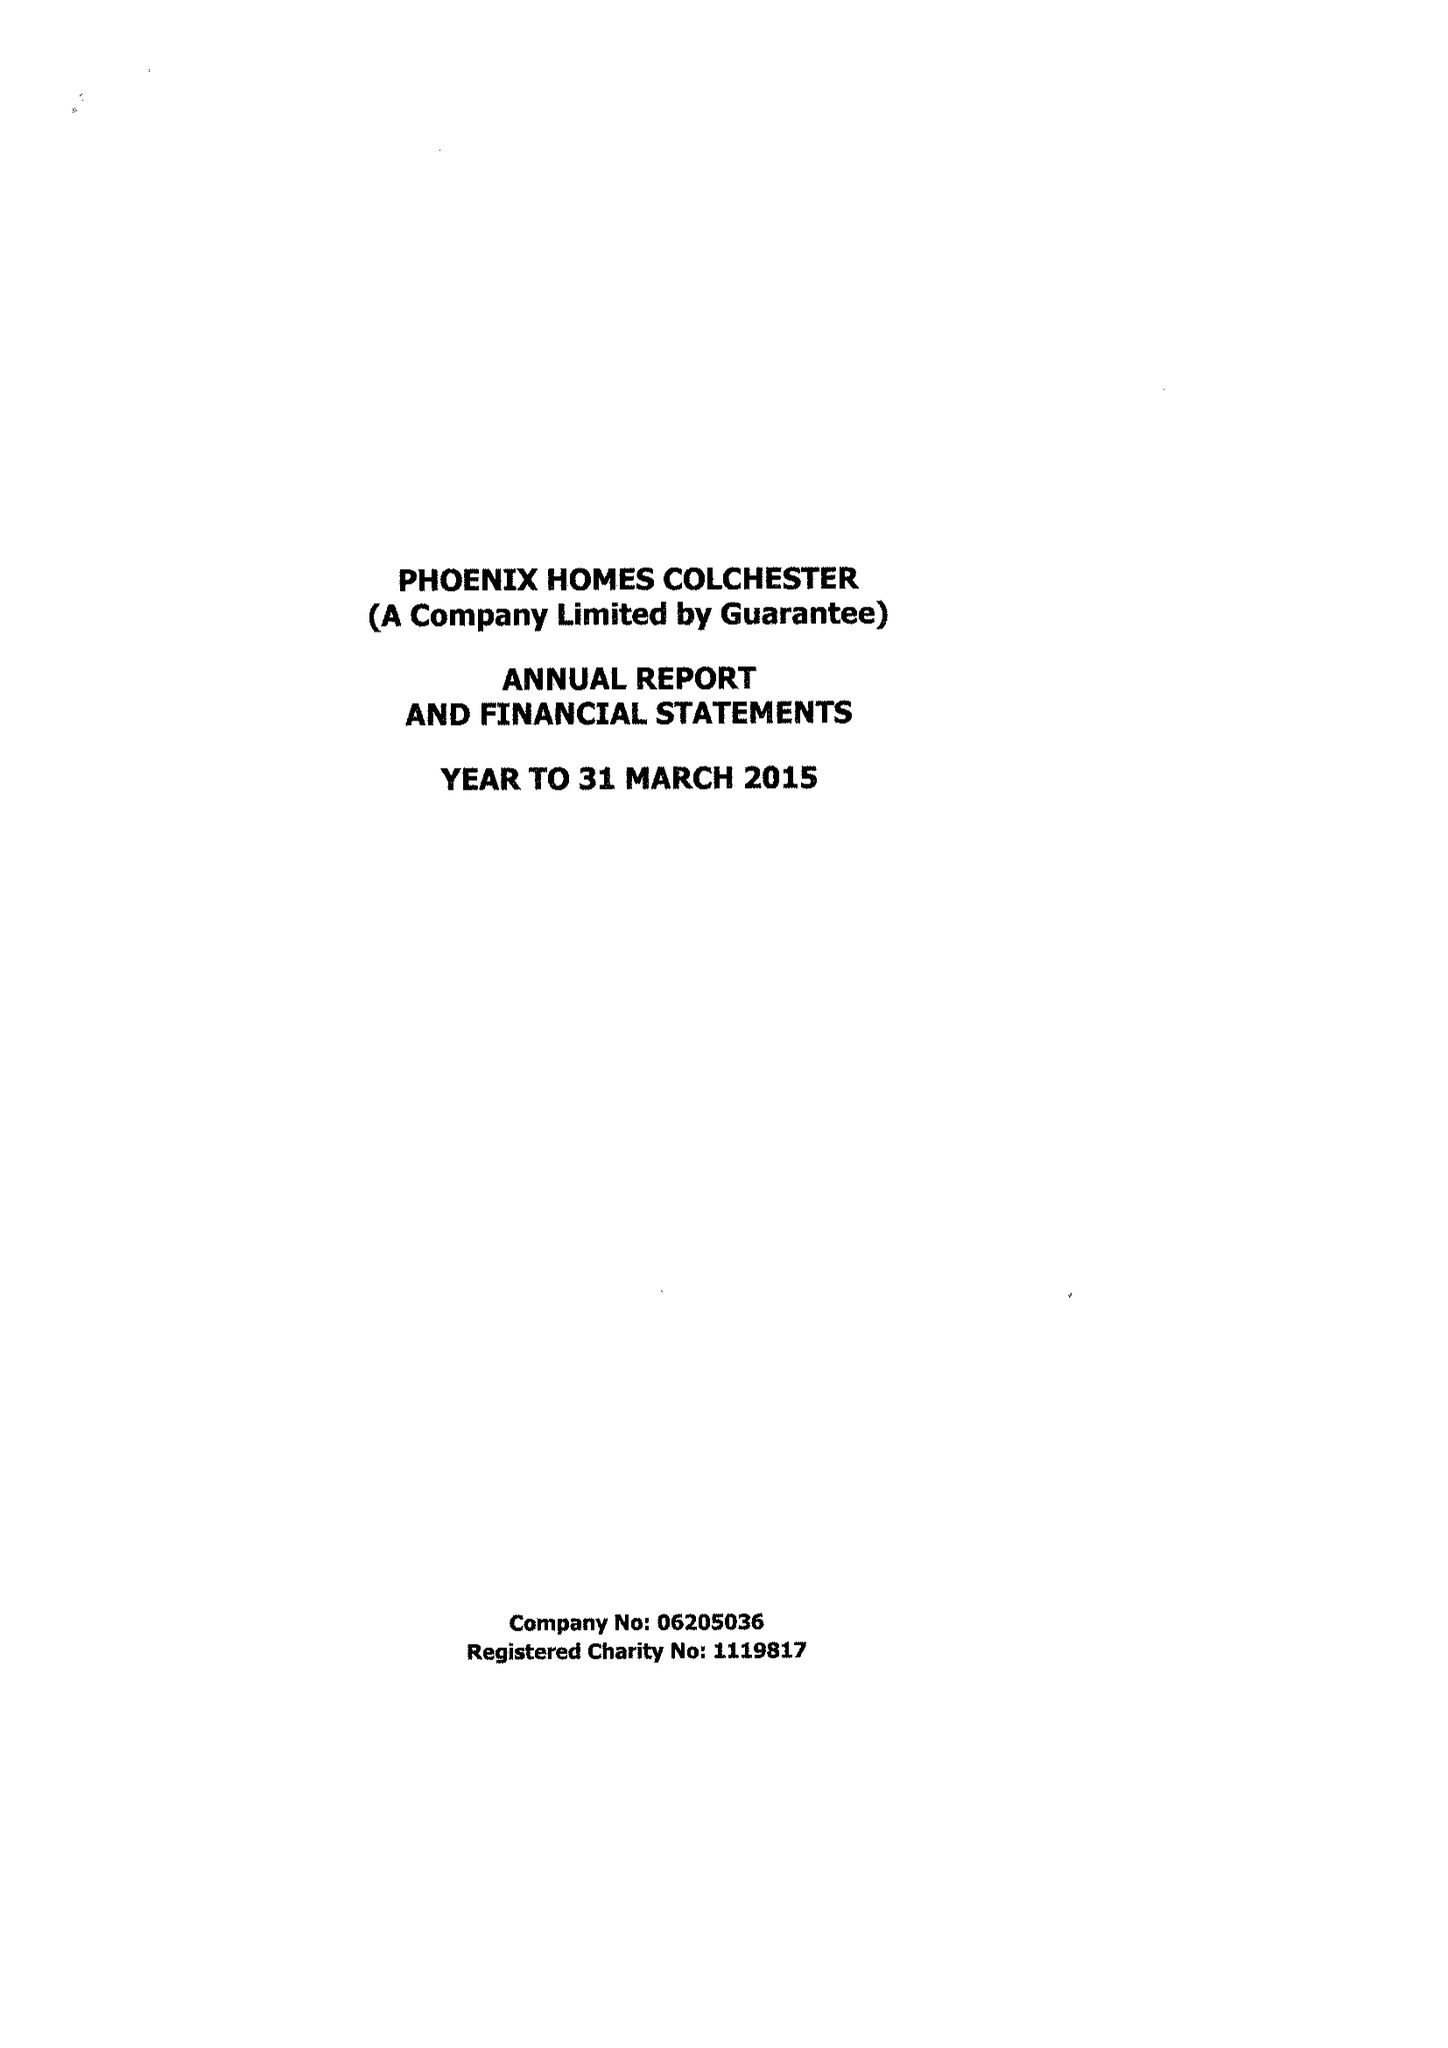What is the value for the charity_number?
Answer the question using a single word or phrase. 1119817 